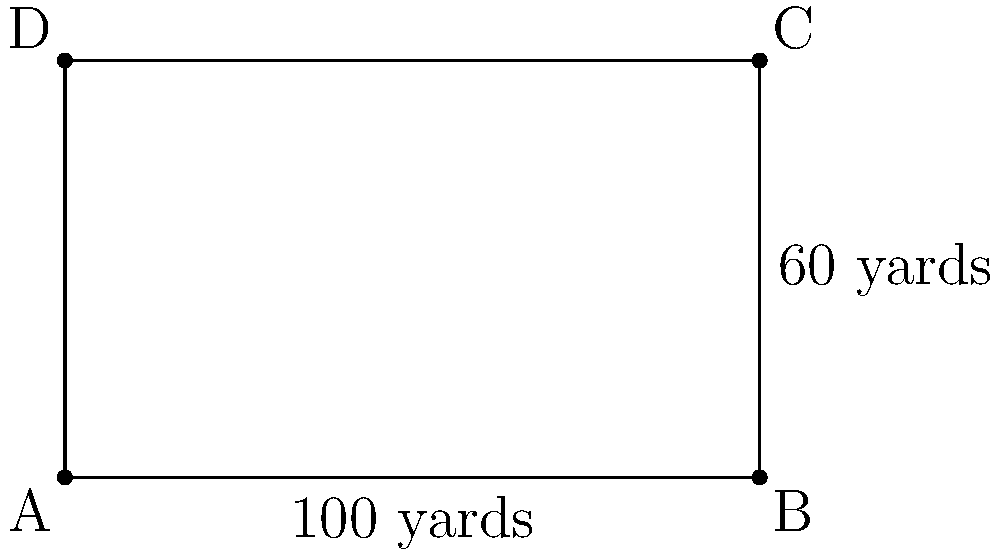As a sports commentator covering the US Track and Field Championships, you're given the coordinates of a rectangular running track: A(0,0), B(100,0), C(100,60), and D(0,60) in yards. What is the area of this track in square yards? To find the area of the rectangular track, we need to follow these steps:

1) In a rectangle, the area is calculated by multiplying the length by the width.

2) From the given coordinates, we can determine:
   - Length (distance from A to B or D to C) = 100 yards
   - Width (distance from A to D or B to C) = 60 yards

3) Apply the area formula:
   $$\text{Area} = \text{length} \times \text{width}$$
   $$\text{Area} = 100 \text{ yards} \times 60 \text{ yards}$$
   $$\text{Area} = 6000 \text{ square yards}$$

Therefore, the area of the rectangular running track is 6000 square yards.
Answer: 6000 square yards 